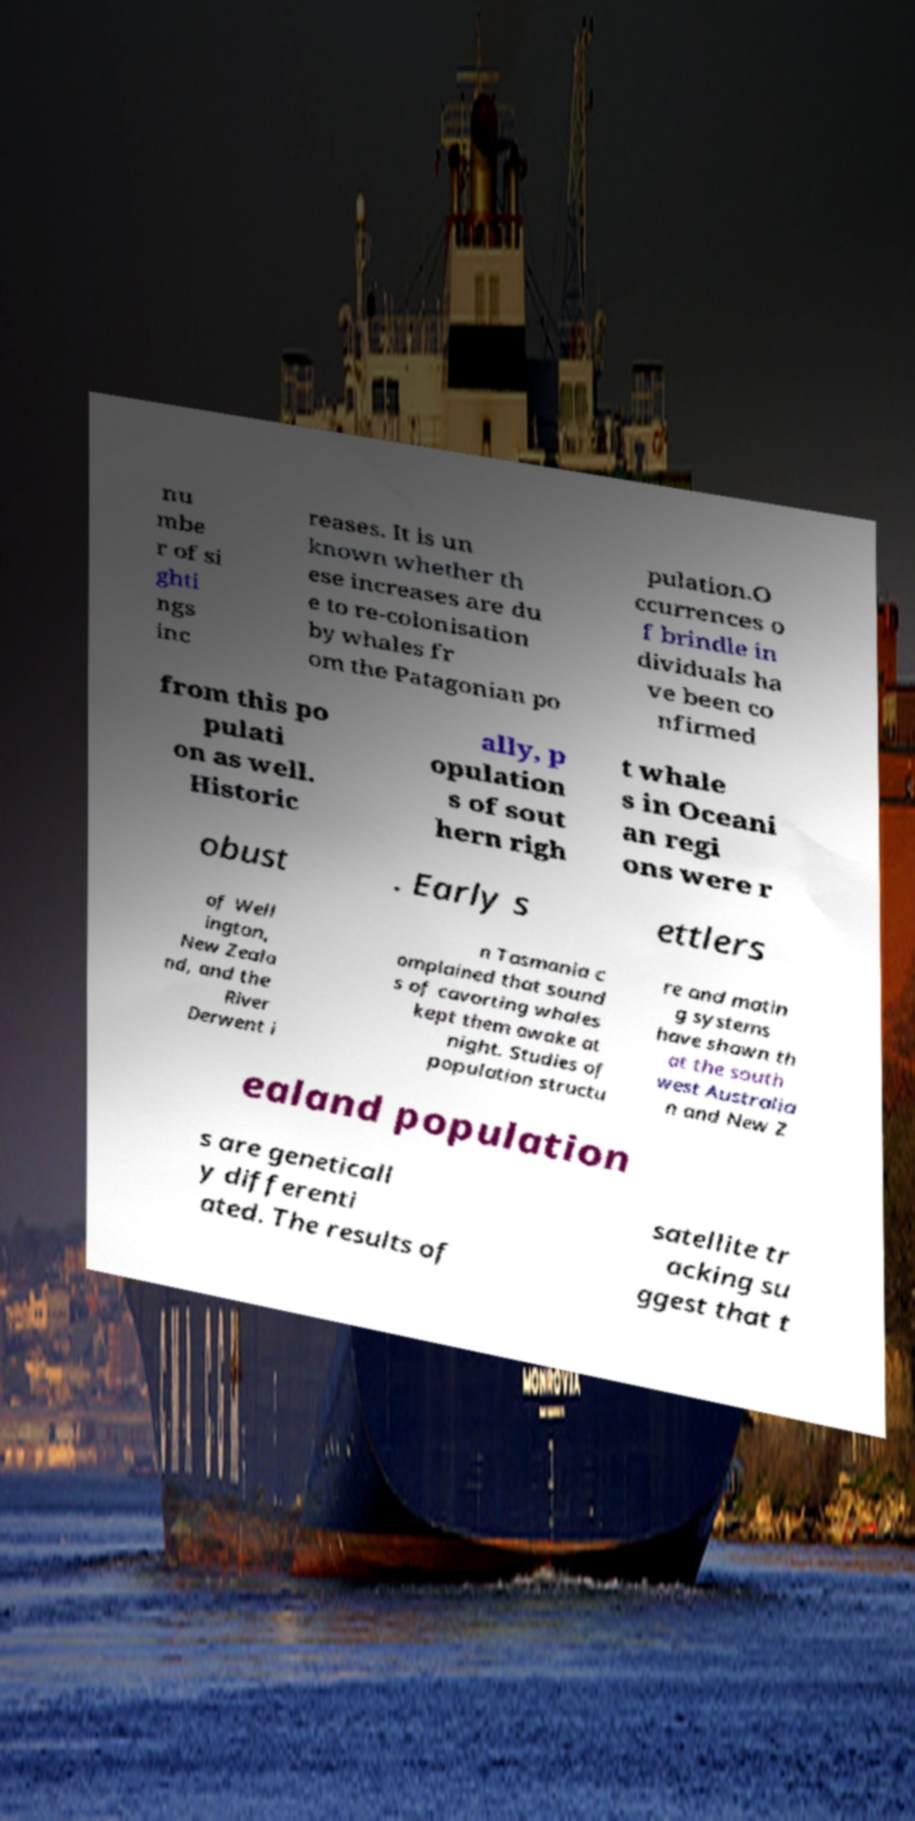Can you read and provide the text displayed in the image?This photo seems to have some interesting text. Can you extract and type it out for me? nu mbe r of si ghti ngs inc reases. It is un known whether th ese increases are du e to re-colonisation by whales fr om the Patagonian po pulation.O ccurrences o f brindle in dividuals ha ve been co nfirmed from this po pulati on as well. Historic ally, p opulation s of sout hern righ t whale s in Oceani an regi ons were r obust . Early s ettlers of Well ington, New Zeala nd, and the River Derwent i n Tasmania c omplained that sound s of cavorting whales kept them awake at night. Studies of population structu re and matin g systems have shown th at the south west Australia n and New Z ealand population s are geneticall y differenti ated. The results of satellite tr acking su ggest that t 